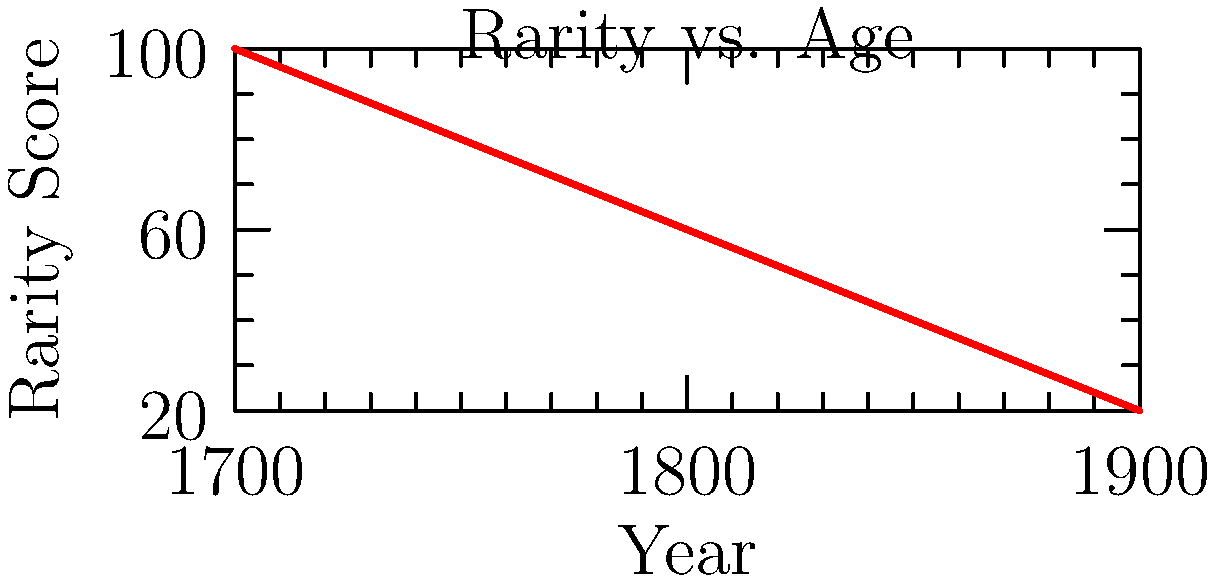Based on the graph showing the relationship between a document's age and its rarity score, estimate the rarity score of a historical document dated 1825. How would you adjust this score if the document contains unique watermarks and is written in an uncommon dialect? To determine the rarity score of the historical document, we'll follow these steps:

1. Interpret the graph:
   - The x-axis represents the year (age of the document)
   - The y-axis represents the rarity score
   - The line shows an inverse relationship between age and rarity score

2. Estimate the rarity score for 1825:
   - Locate 1825 on the x-axis (between 1800 and 1850)
   - Find the corresponding y-value on the graph
   - The estimated rarity score is approximately 50

3. Adjust for unique characteristics:
   - Unique watermarks increase rarity
   - Uncommon dialect increases rarity
   - Each feature could potentially increase the score by 10-20 points

4. Calculate the adjusted score:
   - Base score: 50
   - Watermarks adjustment: +15 (average of 10-20)
   - Uncommon dialect adjustment: +15 (average of 10-20)
   - Adjusted score: 50 + 15 + 15 = 80

The final rarity score would be approximately 80, considering both the age and unique features of the document.
Answer: 80 